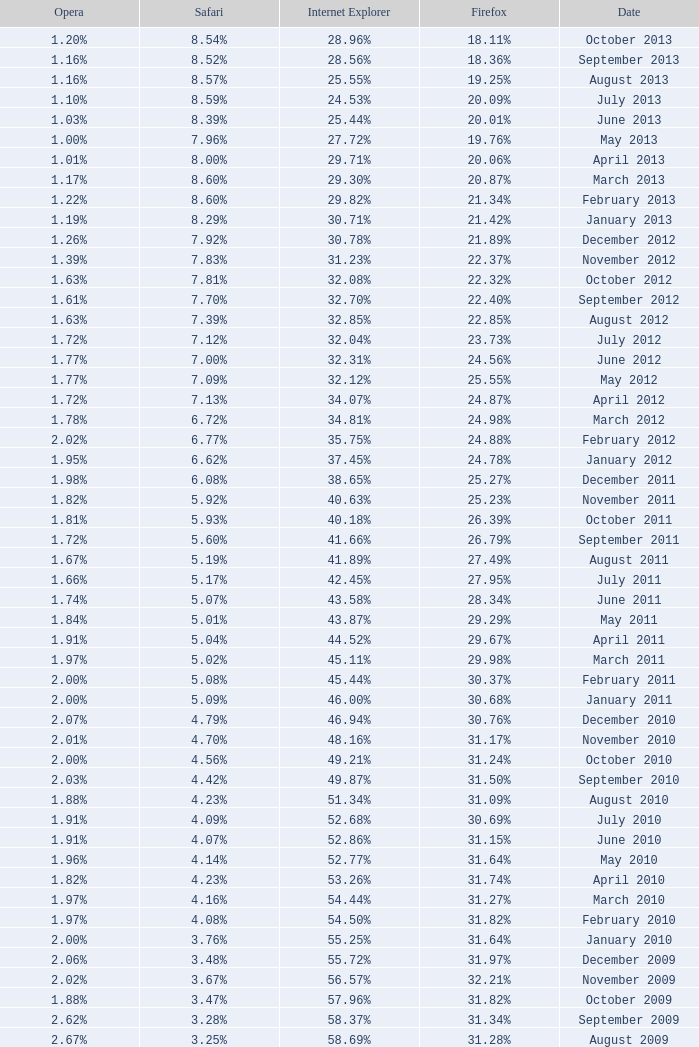What percentage of browsers were using Safari during the period in which 31.27% were using Firefox? 4.16%. 